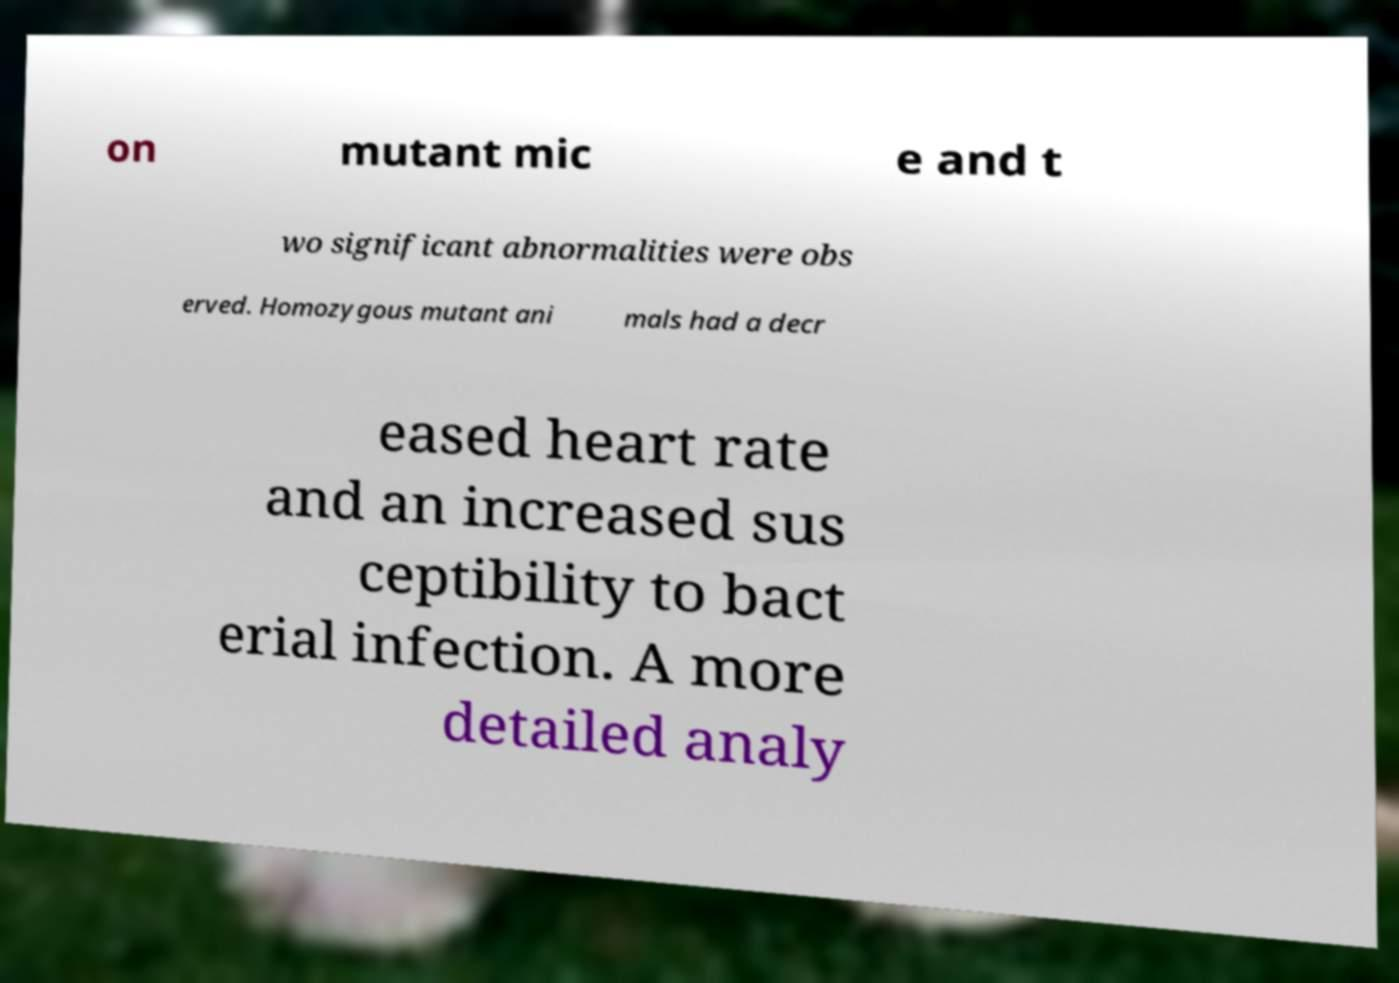Could you assist in decoding the text presented in this image and type it out clearly? on mutant mic e and t wo significant abnormalities were obs erved. Homozygous mutant ani mals had a decr eased heart rate and an increased sus ceptibility to bact erial infection. A more detailed analy 